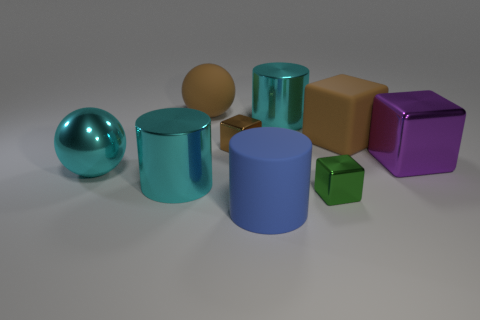Describe the lighting in the image. Where is it coming from? The lighting in the image appears to be soft and diffused, coming from above. There are subtle shadows under the objects that suggest an overhead light source. 